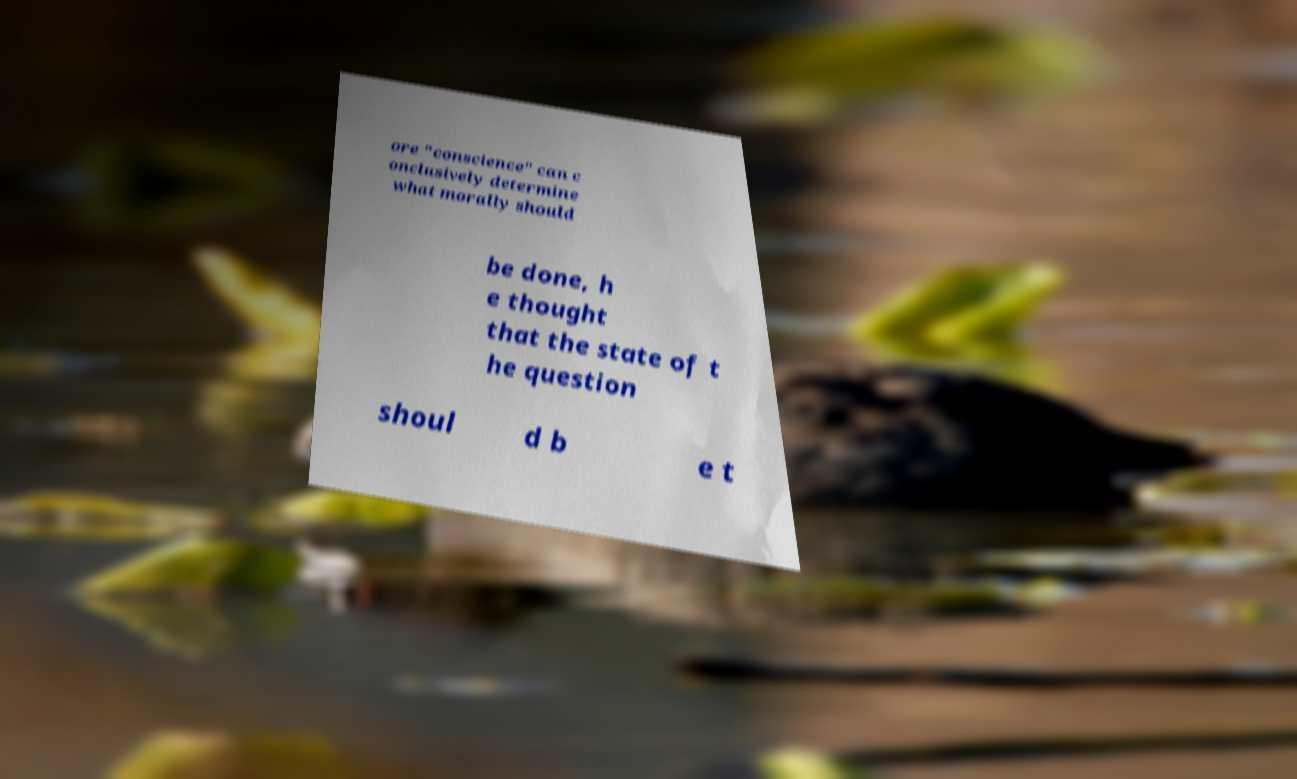I need the written content from this picture converted into text. Can you do that? ore "conscience" can c onclusively determine what morally should be done, h e thought that the state of t he question shoul d b e t 